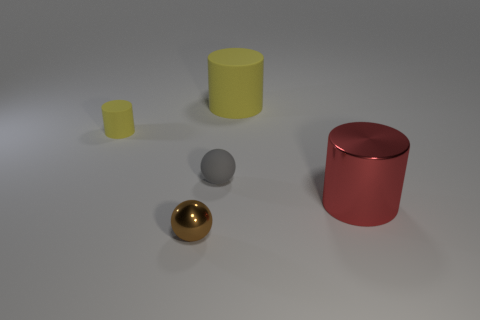Subtract all tiny yellow rubber cylinders. How many cylinders are left? 2 Subtract all gray blocks. How many yellow cylinders are left? 2 Add 1 big yellow cylinders. How many objects exist? 6 Subtract all yellow cylinders. How many cylinders are left? 1 Subtract all spheres. How many objects are left? 3 Add 5 large things. How many large things exist? 7 Subtract 0 purple blocks. How many objects are left? 5 Subtract all brown cylinders. Subtract all green cubes. How many cylinders are left? 3 Subtract all small gray matte objects. Subtract all brown things. How many objects are left? 3 Add 4 small things. How many small things are left? 7 